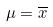Convert formula to latex. <formula><loc_0><loc_0><loc_500><loc_500>\mu = \overline { x }</formula> 